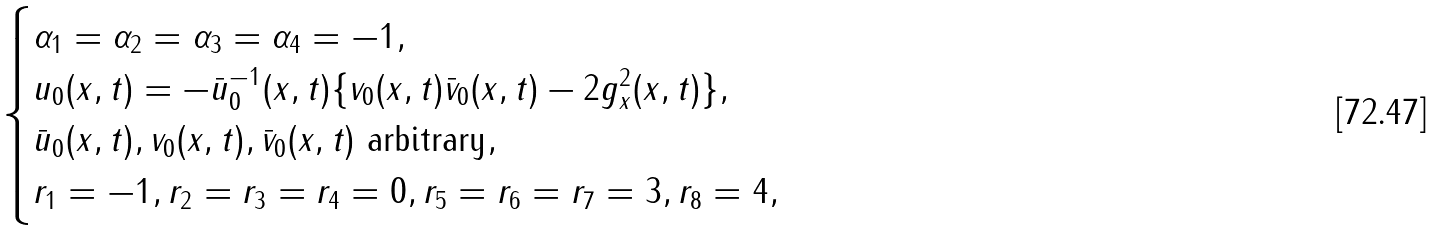<formula> <loc_0><loc_0><loc_500><loc_500>\begin{cases} \alpha _ { 1 } = \alpha _ { 2 } = \alpha _ { 3 } = \alpha _ { 4 } = - 1 , \\ u _ { 0 } ( x , t ) = - \bar { u } _ { 0 } ^ { - 1 } ( x , t ) \{ v _ { 0 } ( x , t ) \bar { v } _ { 0 } ( x , t ) - 2 g _ { x } ^ { 2 } ( x , t ) \} , \\ \bar { u } _ { 0 } ( x , t ) , v _ { 0 } ( x , t ) , \bar { v } _ { 0 } ( x , t ) \text { arbitrary} , \\ r _ { 1 } = - 1 , r _ { 2 } = r _ { 3 } = r _ { 4 } = 0 , r _ { 5 } = r _ { 6 } = r _ { 7 } = 3 , r _ { 8 } = 4 , \end{cases}</formula> 